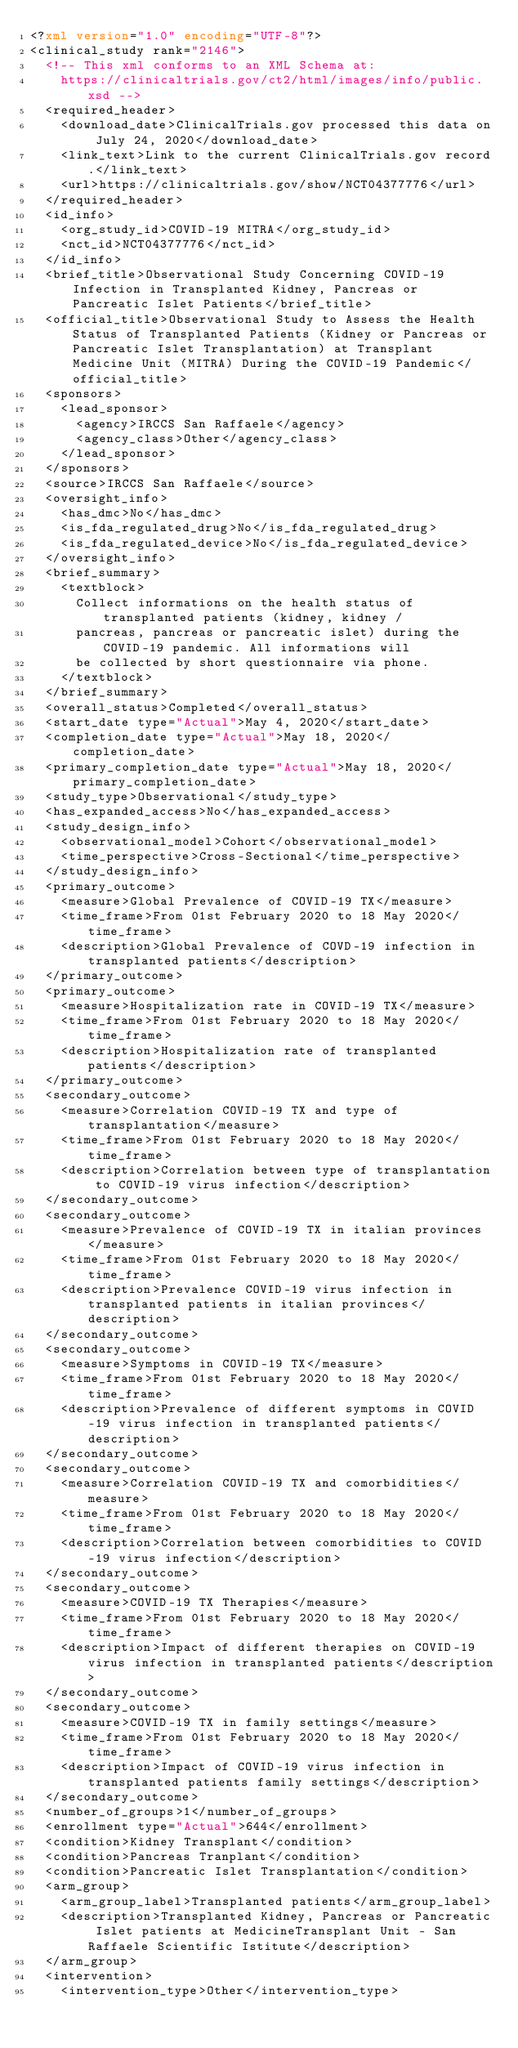Convert code to text. <code><loc_0><loc_0><loc_500><loc_500><_XML_><?xml version="1.0" encoding="UTF-8"?>
<clinical_study rank="2146">
  <!-- This xml conforms to an XML Schema at:
    https://clinicaltrials.gov/ct2/html/images/info/public.xsd -->
  <required_header>
    <download_date>ClinicalTrials.gov processed this data on July 24, 2020</download_date>
    <link_text>Link to the current ClinicalTrials.gov record.</link_text>
    <url>https://clinicaltrials.gov/show/NCT04377776</url>
  </required_header>
  <id_info>
    <org_study_id>COVID-19 MITRA</org_study_id>
    <nct_id>NCT04377776</nct_id>
  </id_info>
  <brief_title>Observational Study Concerning COVID-19 Infection in Transplanted Kidney, Pancreas or Pancreatic Islet Patients</brief_title>
  <official_title>Observational Study to Assess the Health Status of Transplanted Patients (Kidney or Pancreas or Pancreatic Islet Transplantation) at Transplant Medicine Unit (MITRA) During the COVID-19 Pandemic</official_title>
  <sponsors>
    <lead_sponsor>
      <agency>IRCCS San Raffaele</agency>
      <agency_class>Other</agency_class>
    </lead_sponsor>
  </sponsors>
  <source>IRCCS San Raffaele</source>
  <oversight_info>
    <has_dmc>No</has_dmc>
    <is_fda_regulated_drug>No</is_fda_regulated_drug>
    <is_fda_regulated_device>No</is_fda_regulated_device>
  </oversight_info>
  <brief_summary>
    <textblock>
      Collect informations on the health status of transplanted patients (kidney, kidney /
      pancreas, pancreas or pancreatic islet) during the COVID-19 pandemic. All informations will
      be collected by short questionnaire via phone.
    </textblock>
  </brief_summary>
  <overall_status>Completed</overall_status>
  <start_date type="Actual">May 4, 2020</start_date>
  <completion_date type="Actual">May 18, 2020</completion_date>
  <primary_completion_date type="Actual">May 18, 2020</primary_completion_date>
  <study_type>Observational</study_type>
  <has_expanded_access>No</has_expanded_access>
  <study_design_info>
    <observational_model>Cohort</observational_model>
    <time_perspective>Cross-Sectional</time_perspective>
  </study_design_info>
  <primary_outcome>
    <measure>Global Prevalence of COVID-19 TX</measure>
    <time_frame>From 01st February 2020 to 18 May 2020</time_frame>
    <description>Global Prevalence of COVD-19 infection in transplanted patients</description>
  </primary_outcome>
  <primary_outcome>
    <measure>Hospitalization rate in COVID-19 TX</measure>
    <time_frame>From 01st February 2020 to 18 May 2020</time_frame>
    <description>Hospitalization rate of transplanted patients</description>
  </primary_outcome>
  <secondary_outcome>
    <measure>Correlation COVID-19 TX and type of transplantation</measure>
    <time_frame>From 01st February 2020 to 18 May 2020</time_frame>
    <description>Correlation between type of transplantation to COVID-19 virus infection</description>
  </secondary_outcome>
  <secondary_outcome>
    <measure>Prevalence of COVID-19 TX in italian provinces</measure>
    <time_frame>From 01st February 2020 to 18 May 2020</time_frame>
    <description>Prevalence COVID-19 virus infection in transplanted patients in italian provinces</description>
  </secondary_outcome>
  <secondary_outcome>
    <measure>Symptoms in COVID-19 TX</measure>
    <time_frame>From 01st February 2020 to 18 May 2020</time_frame>
    <description>Prevalence of different symptoms in COVID-19 virus infection in transplanted patients</description>
  </secondary_outcome>
  <secondary_outcome>
    <measure>Correlation COVID-19 TX and comorbidities</measure>
    <time_frame>From 01st February 2020 to 18 May 2020</time_frame>
    <description>Correlation between comorbidities to COVID-19 virus infection</description>
  </secondary_outcome>
  <secondary_outcome>
    <measure>COVID-19 TX Therapies</measure>
    <time_frame>From 01st February 2020 to 18 May 2020</time_frame>
    <description>Impact of different therapies on COVID-19 virus infection in transplanted patients</description>
  </secondary_outcome>
  <secondary_outcome>
    <measure>COVID-19 TX in family settings</measure>
    <time_frame>From 01st February 2020 to 18 May 2020</time_frame>
    <description>Impact of COVID-19 virus infection in transplanted patients family settings</description>
  </secondary_outcome>
  <number_of_groups>1</number_of_groups>
  <enrollment type="Actual">644</enrollment>
  <condition>Kidney Transplant</condition>
  <condition>Pancreas Tranplant</condition>
  <condition>Pancreatic Islet Transplantation</condition>
  <arm_group>
    <arm_group_label>Transplanted patients</arm_group_label>
    <description>Transplanted Kidney, Pancreas or Pancreatic Islet patients at MedicineTransplant Unit - San Raffaele Scientific Istitute</description>
  </arm_group>
  <intervention>
    <intervention_type>Other</intervention_type></code> 